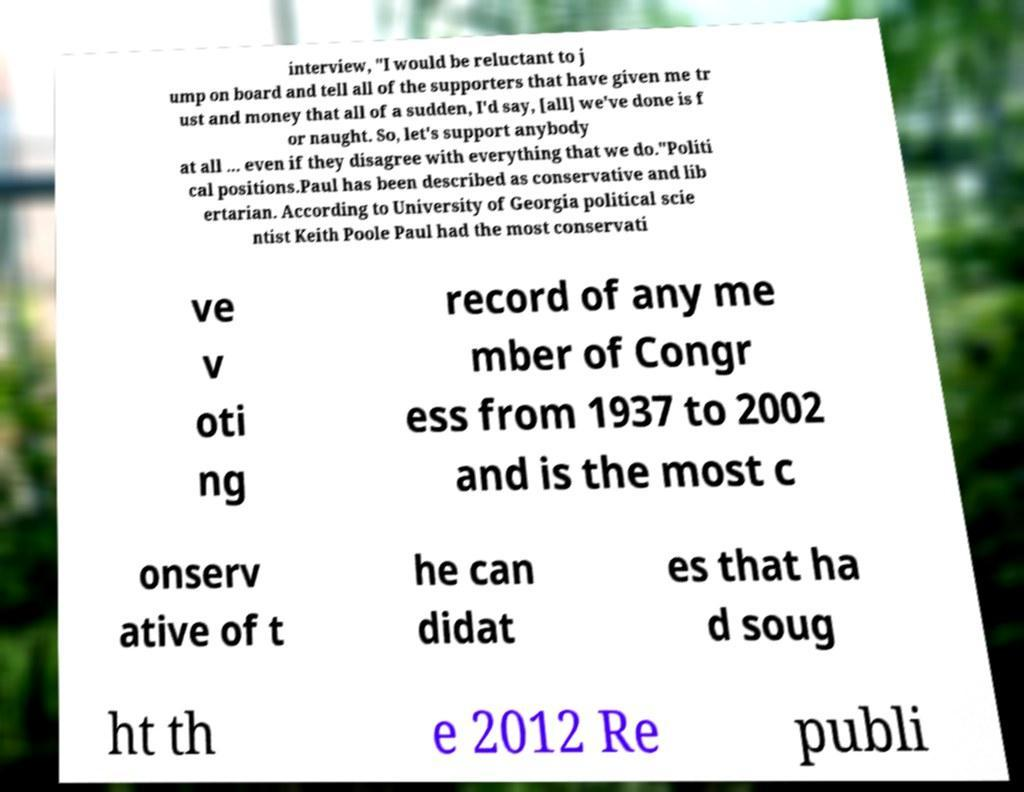Could you extract and type out the text from this image? interview, "I would be reluctant to j ump on board and tell all of the supporters that have given me tr ust and money that all of a sudden, I'd say, [all] we've done is f or naught. So, let's support anybody at all ... even if they disagree with everything that we do."Politi cal positions.Paul has been described as conservative and lib ertarian. According to University of Georgia political scie ntist Keith Poole Paul had the most conservati ve v oti ng record of any me mber of Congr ess from 1937 to 2002 and is the most c onserv ative of t he can didat es that ha d soug ht th e 2012 Re publi 